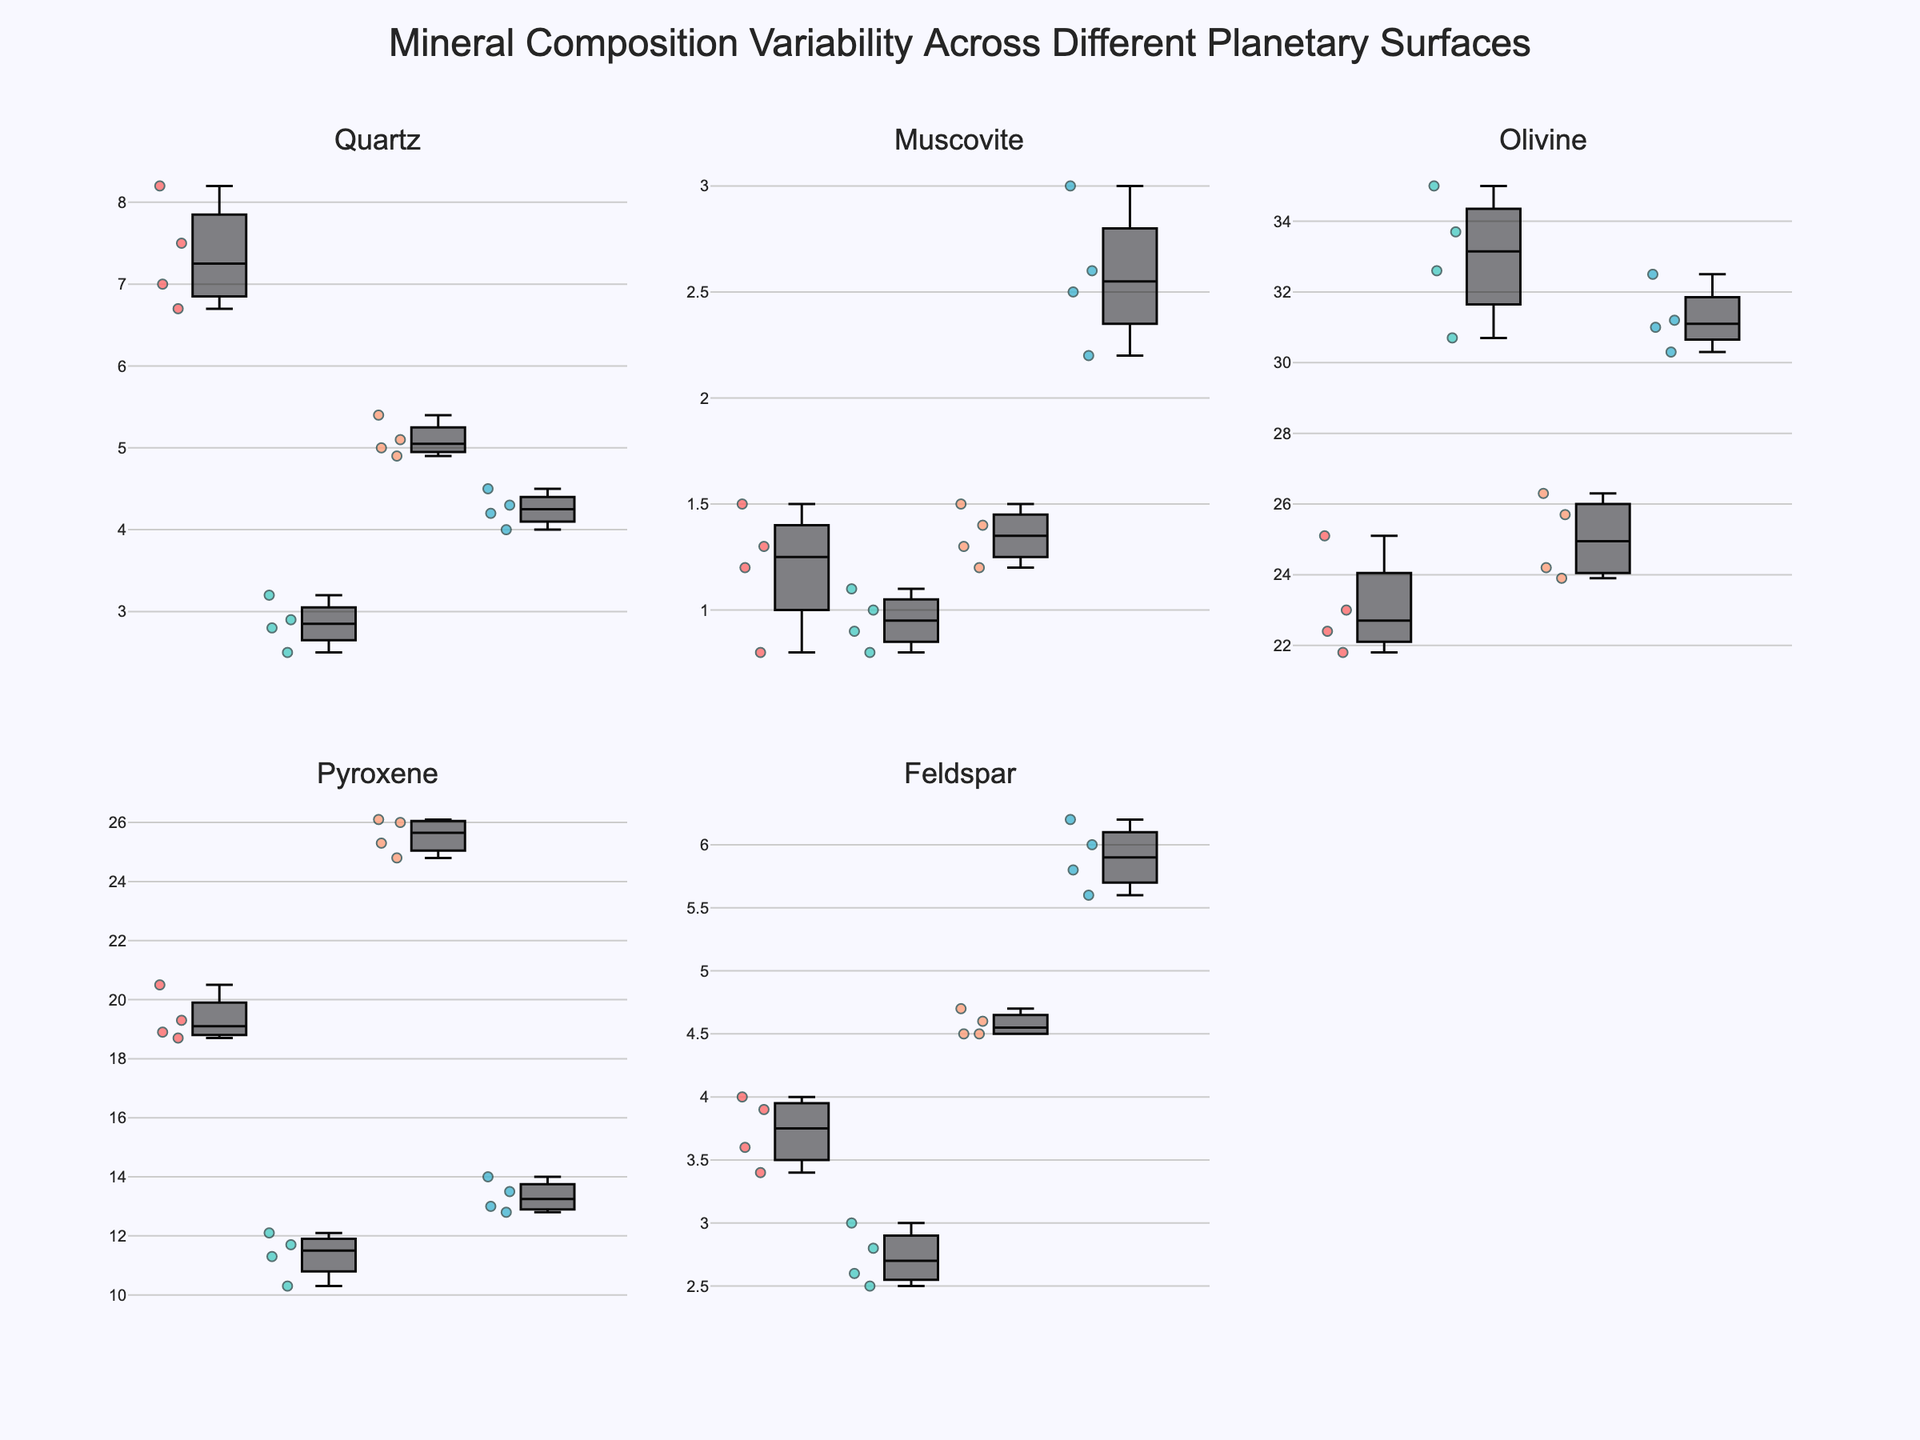What is the title of the plot? The title is located at the top center of the figure. It provides an overview of what the whole figure is about.
Answer: Mineral Composition Variability Across Different Planetary Surfaces Which planetary surface has the highest median Olivine concentration? The box plot for Olivine shows various medians for the different planetary surfaces. The highest median corresponds to the Moon's Tsiolkovskiy Crater.
Answer: Tsiolkovskiy Crater (Moon) How does the median Quartz value on Mars compare to that on Venus? The median Quartz value can be obtained from the central line in each box plot. On Mars, it is higher than on Venus across the respective surfaces.
Answer: Higher on Mars Which planet shows the greatest variability in Pyroxene concentration? The variability is represented by the spread or interquartile range in the box plot. Venus shows the largest spread in the Pyroxene concentration box plots.
Answer: Venus What is the interquartile range (IQR) for Muscovite on Earth? The IQR is found by subtracting the first quartile (Q1) from the third quartile (Q3). Observing the Muscovite plot for Earth, we can estimate the IQR.
Answer: Q3 - Q1 on Earth Which planet has the lowest median Feldspar concentration? The planet with the lowest median is determined by finding the smallest central line value in the Feldspar box plots. The Moon has the lowest median Feldspar concentration.
Answer: The Moon How does the variability of Olivine on the Moon compare to that on Earth? By analyzing the spread of the box plots for Olivine across the Moon and Earth, the Moon displays a larger spread indicating greater variability.
Answer: Greater variability on the Moon Which planetary surface has the most narrow spread of Pyroxene concentrations? The narrow spread is indicated by the smallest range between the quartiles in the Pyroxene plot. Earth surfaces show a narrower spread compared to others.
Answer: Earth Are there any outliers in the Muscovite concentration for Mars? Outliers in box plots are represented by individual points outside the whiskers. No separate points are observed for Mars' Muscovite, indicating no outliers.
Answer: No Which surface on Venus has the highest observed Olivine value? Observing the upper extremes of the box plots for Olivine on Venus, Maxwell Montes shows the highest single observed value.
Answer: Maxwell Montes (Venus) 